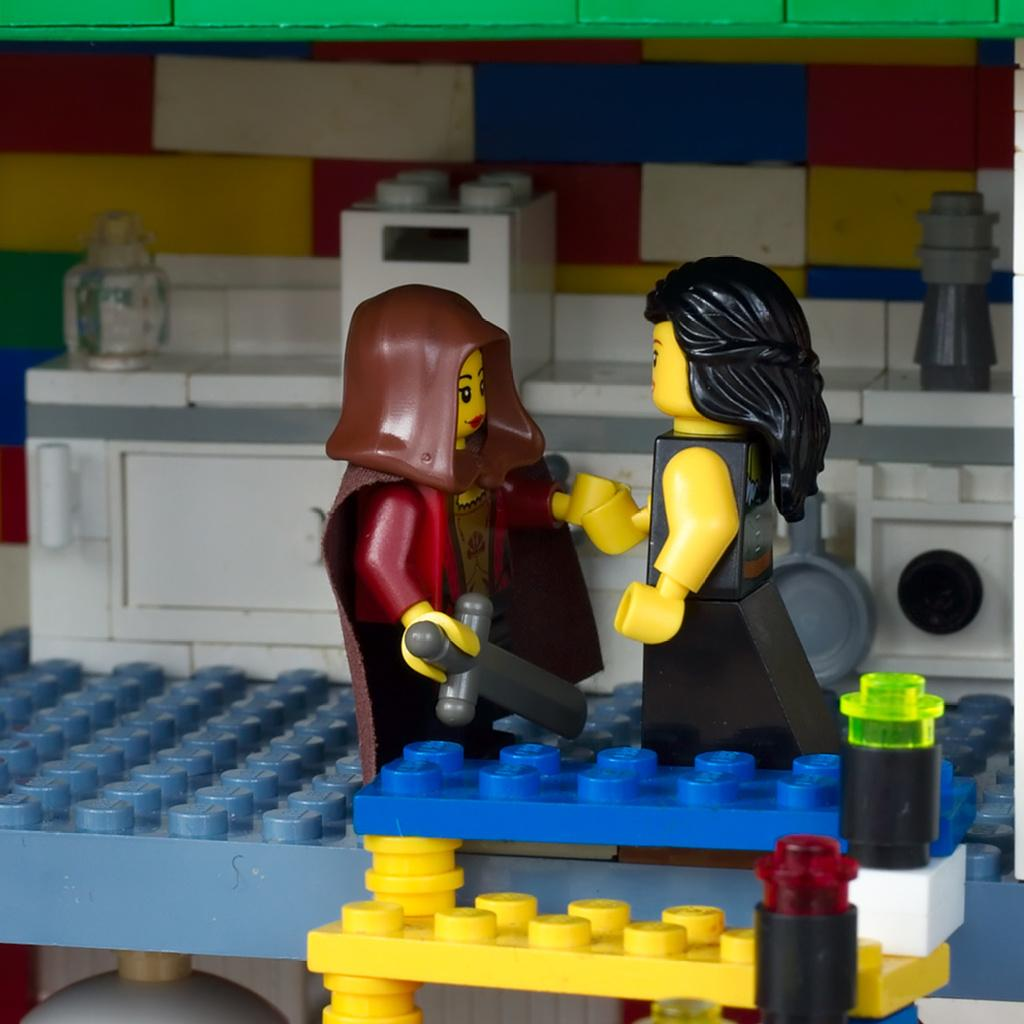How many toys can be seen in the image? There are two toys in the image. What colors are the toys? The toys are in black, yellow, and maroon colors. What other objects are present in the image besides the toys? There are blocks in the image. What colors are the blocks? The blocks are in blue and yellow colors. What can be observed about the background wall in the image? The background wall is in multiple colors. Is there a stream of water visible in the image? No, there is no stream of water present in the image. 